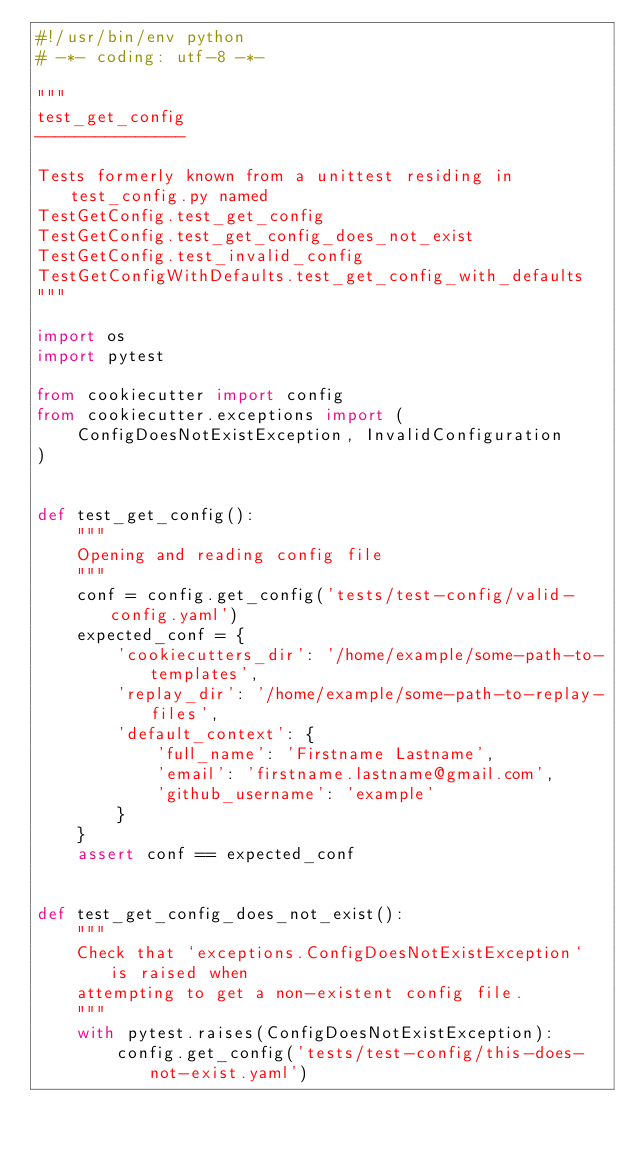Convert code to text. <code><loc_0><loc_0><loc_500><loc_500><_Python_>#!/usr/bin/env python
# -*- coding: utf-8 -*-

"""
test_get_config
---------------

Tests formerly known from a unittest residing in test_config.py named
TestGetConfig.test_get_config
TestGetConfig.test_get_config_does_not_exist
TestGetConfig.test_invalid_config
TestGetConfigWithDefaults.test_get_config_with_defaults
"""

import os
import pytest

from cookiecutter import config
from cookiecutter.exceptions import (
    ConfigDoesNotExistException, InvalidConfiguration
)


def test_get_config():
    """
    Opening and reading config file
    """
    conf = config.get_config('tests/test-config/valid-config.yaml')
    expected_conf = {
        'cookiecutters_dir': '/home/example/some-path-to-templates',
        'replay_dir': '/home/example/some-path-to-replay-files',
        'default_context': {
            'full_name': 'Firstname Lastname',
            'email': 'firstname.lastname@gmail.com',
            'github_username': 'example'
        }
    }
    assert conf == expected_conf


def test_get_config_does_not_exist():
    """
    Check that `exceptions.ConfigDoesNotExistException` is raised when
    attempting to get a non-existent config file.
    """
    with pytest.raises(ConfigDoesNotExistException):
        config.get_config('tests/test-config/this-does-not-exist.yaml')

</code> 